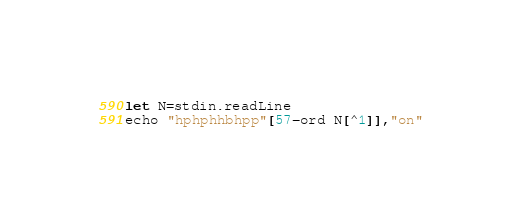Convert code to text. <code><loc_0><loc_0><loc_500><loc_500><_Nim_>let N=stdin.readLine
echo "hphphhbhpp"[57-ord N[^1]],"on"</code> 